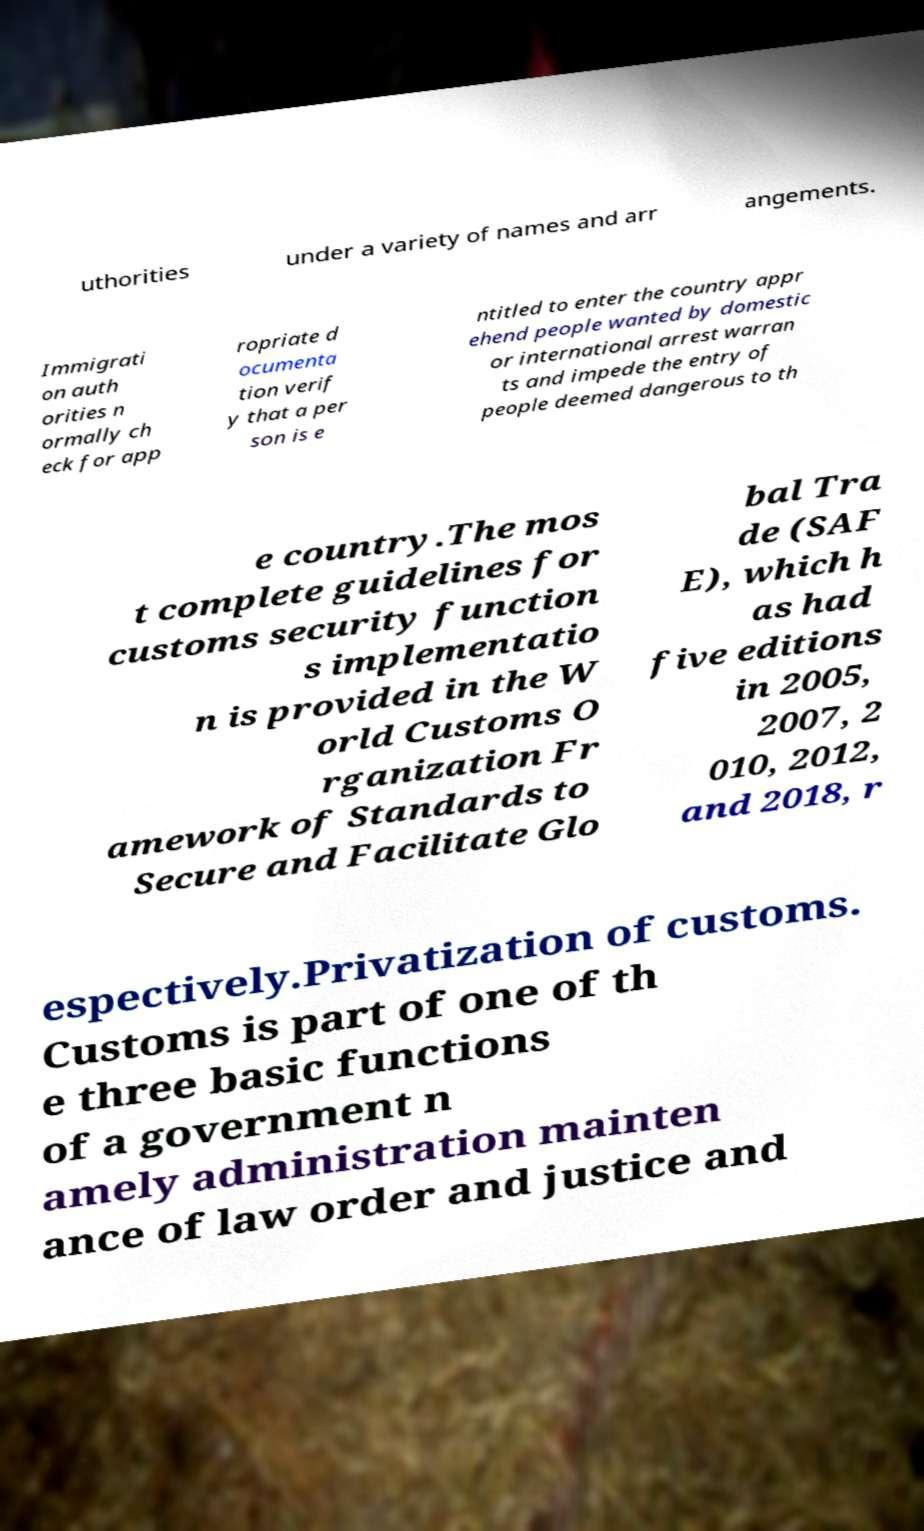For documentation purposes, I need the text within this image transcribed. Could you provide that? uthorities under a variety of names and arr angements. Immigrati on auth orities n ormally ch eck for app ropriate d ocumenta tion verif y that a per son is e ntitled to enter the country appr ehend people wanted by domestic or international arrest warran ts and impede the entry of people deemed dangerous to th e country.The mos t complete guidelines for customs security function s implementatio n is provided in the W orld Customs O rganization Fr amework of Standards to Secure and Facilitate Glo bal Tra de (SAF E), which h as had five editions in 2005, 2007, 2 010, 2012, and 2018, r espectively.Privatization of customs. Customs is part of one of th e three basic functions of a government n amely administration mainten ance of law order and justice and 